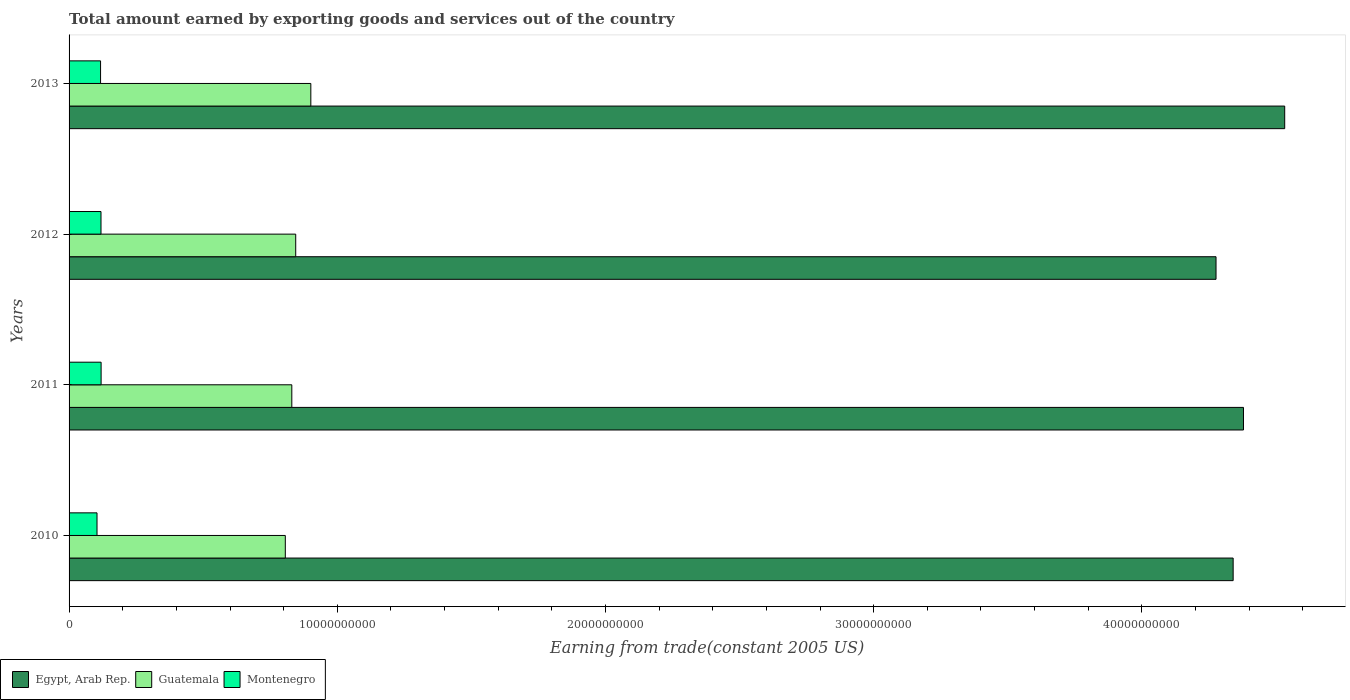How many groups of bars are there?
Your answer should be very brief. 4. Are the number of bars per tick equal to the number of legend labels?
Ensure brevity in your answer.  Yes. In how many cases, is the number of bars for a given year not equal to the number of legend labels?
Offer a very short reply. 0. What is the total amount earned by exporting goods and services in Egypt, Arab Rep. in 2013?
Your answer should be very brief. 4.53e+1. Across all years, what is the maximum total amount earned by exporting goods and services in Guatemala?
Provide a short and direct response. 9.01e+09. Across all years, what is the minimum total amount earned by exporting goods and services in Guatemala?
Your response must be concise. 8.06e+09. In which year was the total amount earned by exporting goods and services in Montenegro minimum?
Your answer should be very brief. 2010. What is the total total amount earned by exporting goods and services in Egypt, Arab Rep. in the graph?
Provide a succinct answer. 1.75e+11. What is the difference between the total amount earned by exporting goods and services in Montenegro in 2012 and that in 2013?
Provide a succinct answer. 1.59e+07. What is the difference between the total amount earned by exporting goods and services in Guatemala in 2010 and the total amount earned by exporting goods and services in Egypt, Arab Rep. in 2011?
Your answer should be compact. -3.57e+1. What is the average total amount earned by exporting goods and services in Guatemala per year?
Ensure brevity in your answer.  8.46e+09. In the year 2010, what is the difference between the total amount earned by exporting goods and services in Guatemala and total amount earned by exporting goods and services in Montenegro?
Keep it short and to the point. 7.02e+09. In how many years, is the total amount earned by exporting goods and services in Montenegro greater than 32000000000 US$?
Make the answer very short. 0. What is the ratio of the total amount earned by exporting goods and services in Montenegro in 2010 to that in 2012?
Provide a succinct answer. 0.88. Is the difference between the total amount earned by exporting goods and services in Guatemala in 2011 and 2013 greater than the difference between the total amount earned by exporting goods and services in Montenegro in 2011 and 2013?
Provide a succinct answer. No. What is the difference between the highest and the second highest total amount earned by exporting goods and services in Egypt, Arab Rep.?
Make the answer very short. 1.54e+09. What is the difference between the highest and the lowest total amount earned by exporting goods and services in Egypt, Arab Rep.?
Make the answer very short. 2.56e+09. In how many years, is the total amount earned by exporting goods and services in Guatemala greater than the average total amount earned by exporting goods and services in Guatemala taken over all years?
Offer a very short reply. 1. What does the 1st bar from the top in 2010 represents?
Your answer should be very brief. Montenegro. What does the 3rd bar from the bottom in 2012 represents?
Your answer should be compact. Montenegro. Are the values on the major ticks of X-axis written in scientific E-notation?
Ensure brevity in your answer.  No. Does the graph contain grids?
Give a very brief answer. No. How many legend labels are there?
Provide a short and direct response. 3. What is the title of the graph?
Give a very brief answer. Total amount earned by exporting goods and services out of the country. Does "Mali" appear as one of the legend labels in the graph?
Your response must be concise. No. What is the label or title of the X-axis?
Give a very brief answer. Earning from trade(constant 2005 US). What is the label or title of the Y-axis?
Offer a terse response. Years. What is the Earning from trade(constant 2005 US) in Egypt, Arab Rep. in 2010?
Your answer should be very brief. 4.34e+1. What is the Earning from trade(constant 2005 US) in Guatemala in 2010?
Keep it short and to the point. 8.06e+09. What is the Earning from trade(constant 2005 US) in Montenegro in 2010?
Your answer should be compact. 1.04e+09. What is the Earning from trade(constant 2005 US) of Egypt, Arab Rep. in 2011?
Make the answer very short. 4.38e+1. What is the Earning from trade(constant 2005 US) of Guatemala in 2011?
Offer a terse response. 8.31e+09. What is the Earning from trade(constant 2005 US) of Montenegro in 2011?
Provide a succinct answer. 1.19e+09. What is the Earning from trade(constant 2005 US) of Egypt, Arab Rep. in 2012?
Your answer should be compact. 4.28e+1. What is the Earning from trade(constant 2005 US) in Guatemala in 2012?
Provide a short and direct response. 8.45e+09. What is the Earning from trade(constant 2005 US) in Montenegro in 2012?
Ensure brevity in your answer.  1.19e+09. What is the Earning from trade(constant 2005 US) in Egypt, Arab Rep. in 2013?
Provide a succinct answer. 4.53e+1. What is the Earning from trade(constant 2005 US) in Guatemala in 2013?
Give a very brief answer. 9.01e+09. What is the Earning from trade(constant 2005 US) in Montenegro in 2013?
Your answer should be compact. 1.17e+09. Across all years, what is the maximum Earning from trade(constant 2005 US) in Egypt, Arab Rep.?
Offer a very short reply. 4.53e+1. Across all years, what is the maximum Earning from trade(constant 2005 US) of Guatemala?
Provide a succinct answer. 9.01e+09. Across all years, what is the maximum Earning from trade(constant 2005 US) in Montenegro?
Provide a short and direct response. 1.19e+09. Across all years, what is the minimum Earning from trade(constant 2005 US) of Egypt, Arab Rep.?
Give a very brief answer. 4.28e+1. Across all years, what is the minimum Earning from trade(constant 2005 US) in Guatemala?
Provide a succinct answer. 8.06e+09. Across all years, what is the minimum Earning from trade(constant 2005 US) of Montenegro?
Your answer should be compact. 1.04e+09. What is the total Earning from trade(constant 2005 US) of Egypt, Arab Rep. in the graph?
Ensure brevity in your answer.  1.75e+11. What is the total Earning from trade(constant 2005 US) of Guatemala in the graph?
Make the answer very short. 3.38e+1. What is the total Earning from trade(constant 2005 US) in Montenegro in the graph?
Provide a succinct answer. 4.60e+09. What is the difference between the Earning from trade(constant 2005 US) of Egypt, Arab Rep. in 2010 and that in 2011?
Offer a very short reply. -3.85e+08. What is the difference between the Earning from trade(constant 2005 US) of Guatemala in 2010 and that in 2011?
Offer a terse response. -2.43e+08. What is the difference between the Earning from trade(constant 2005 US) in Montenegro in 2010 and that in 2011?
Offer a terse response. -1.52e+08. What is the difference between the Earning from trade(constant 2005 US) in Egypt, Arab Rep. in 2010 and that in 2012?
Give a very brief answer. 6.38e+08. What is the difference between the Earning from trade(constant 2005 US) of Guatemala in 2010 and that in 2012?
Give a very brief answer. -3.88e+08. What is the difference between the Earning from trade(constant 2005 US) in Montenegro in 2010 and that in 2012?
Keep it short and to the point. -1.48e+08. What is the difference between the Earning from trade(constant 2005 US) of Egypt, Arab Rep. in 2010 and that in 2013?
Keep it short and to the point. -1.92e+09. What is the difference between the Earning from trade(constant 2005 US) of Guatemala in 2010 and that in 2013?
Your response must be concise. -9.51e+08. What is the difference between the Earning from trade(constant 2005 US) of Montenegro in 2010 and that in 2013?
Your answer should be very brief. -1.32e+08. What is the difference between the Earning from trade(constant 2005 US) of Egypt, Arab Rep. in 2011 and that in 2012?
Provide a succinct answer. 1.02e+09. What is the difference between the Earning from trade(constant 2005 US) in Guatemala in 2011 and that in 2012?
Offer a terse response. -1.46e+08. What is the difference between the Earning from trade(constant 2005 US) in Montenegro in 2011 and that in 2012?
Offer a very short reply. 4.06e+06. What is the difference between the Earning from trade(constant 2005 US) of Egypt, Arab Rep. in 2011 and that in 2013?
Provide a short and direct response. -1.54e+09. What is the difference between the Earning from trade(constant 2005 US) in Guatemala in 2011 and that in 2013?
Your answer should be very brief. -7.09e+08. What is the difference between the Earning from trade(constant 2005 US) in Montenegro in 2011 and that in 2013?
Give a very brief answer. 2.00e+07. What is the difference between the Earning from trade(constant 2005 US) in Egypt, Arab Rep. in 2012 and that in 2013?
Your response must be concise. -2.56e+09. What is the difference between the Earning from trade(constant 2005 US) in Guatemala in 2012 and that in 2013?
Make the answer very short. -5.63e+08. What is the difference between the Earning from trade(constant 2005 US) in Montenegro in 2012 and that in 2013?
Offer a very short reply. 1.59e+07. What is the difference between the Earning from trade(constant 2005 US) in Egypt, Arab Rep. in 2010 and the Earning from trade(constant 2005 US) in Guatemala in 2011?
Keep it short and to the point. 3.51e+1. What is the difference between the Earning from trade(constant 2005 US) in Egypt, Arab Rep. in 2010 and the Earning from trade(constant 2005 US) in Montenegro in 2011?
Give a very brief answer. 4.22e+1. What is the difference between the Earning from trade(constant 2005 US) in Guatemala in 2010 and the Earning from trade(constant 2005 US) in Montenegro in 2011?
Make the answer very short. 6.87e+09. What is the difference between the Earning from trade(constant 2005 US) in Egypt, Arab Rep. in 2010 and the Earning from trade(constant 2005 US) in Guatemala in 2012?
Keep it short and to the point. 3.50e+1. What is the difference between the Earning from trade(constant 2005 US) in Egypt, Arab Rep. in 2010 and the Earning from trade(constant 2005 US) in Montenegro in 2012?
Provide a succinct answer. 4.22e+1. What is the difference between the Earning from trade(constant 2005 US) in Guatemala in 2010 and the Earning from trade(constant 2005 US) in Montenegro in 2012?
Your response must be concise. 6.87e+09. What is the difference between the Earning from trade(constant 2005 US) in Egypt, Arab Rep. in 2010 and the Earning from trade(constant 2005 US) in Guatemala in 2013?
Give a very brief answer. 3.44e+1. What is the difference between the Earning from trade(constant 2005 US) in Egypt, Arab Rep. in 2010 and the Earning from trade(constant 2005 US) in Montenegro in 2013?
Ensure brevity in your answer.  4.22e+1. What is the difference between the Earning from trade(constant 2005 US) of Guatemala in 2010 and the Earning from trade(constant 2005 US) of Montenegro in 2013?
Provide a short and direct response. 6.89e+09. What is the difference between the Earning from trade(constant 2005 US) in Egypt, Arab Rep. in 2011 and the Earning from trade(constant 2005 US) in Guatemala in 2012?
Your response must be concise. 3.53e+1. What is the difference between the Earning from trade(constant 2005 US) of Egypt, Arab Rep. in 2011 and the Earning from trade(constant 2005 US) of Montenegro in 2012?
Provide a succinct answer. 4.26e+1. What is the difference between the Earning from trade(constant 2005 US) in Guatemala in 2011 and the Earning from trade(constant 2005 US) in Montenegro in 2012?
Provide a succinct answer. 7.11e+09. What is the difference between the Earning from trade(constant 2005 US) of Egypt, Arab Rep. in 2011 and the Earning from trade(constant 2005 US) of Guatemala in 2013?
Your answer should be compact. 3.48e+1. What is the difference between the Earning from trade(constant 2005 US) of Egypt, Arab Rep. in 2011 and the Earning from trade(constant 2005 US) of Montenegro in 2013?
Ensure brevity in your answer.  4.26e+1. What is the difference between the Earning from trade(constant 2005 US) of Guatemala in 2011 and the Earning from trade(constant 2005 US) of Montenegro in 2013?
Ensure brevity in your answer.  7.13e+09. What is the difference between the Earning from trade(constant 2005 US) in Egypt, Arab Rep. in 2012 and the Earning from trade(constant 2005 US) in Guatemala in 2013?
Your answer should be very brief. 3.38e+1. What is the difference between the Earning from trade(constant 2005 US) in Egypt, Arab Rep. in 2012 and the Earning from trade(constant 2005 US) in Montenegro in 2013?
Ensure brevity in your answer.  4.16e+1. What is the difference between the Earning from trade(constant 2005 US) in Guatemala in 2012 and the Earning from trade(constant 2005 US) in Montenegro in 2013?
Your response must be concise. 7.28e+09. What is the average Earning from trade(constant 2005 US) of Egypt, Arab Rep. per year?
Your answer should be very brief. 4.38e+1. What is the average Earning from trade(constant 2005 US) in Guatemala per year?
Provide a short and direct response. 8.46e+09. What is the average Earning from trade(constant 2005 US) in Montenegro per year?
Make the answer very short. 1.15e+09. In the year 2010, what is the difference between the Earning from trade(constant 2005 US) in Egypt, Arab Rep. and Earning from trade(constant 2005 US) in Guatemala?
Provide a short and direct response. 3.53e+1. In the year 2010, what is the difference between the Earning from trade(constant 2005 US) of Egypt, Arab Rep. and Earning from trade(constant 2005 US) of Montenegro?
Provide a succinct answer. 4.24e+1. In the year 2010, what is the difference between the Earning from trade(constant 2005 US) in Guatemala and Earning from trade(constant 2005 US) in Montenegro?
Offer a terse response. 7.02e+09. In the year 2011, what is the difference between the Earning from trade(constant 2005 US) of Egypt, Arab Rep. and Earning from trade(constant 2005 US) of Guatemala?
Provide a succinct answer. 3.55e+1. In the year 2011, what is the difference between the Earning from trade(constant 2005 US) of Egypt, Arab Rep. and Earning from trade(constant 2005 US) of Montenegro?
Provide a short and direct response. 4.26e+1. In the year 2011, what is the difference between the Earning from trade(constant 2005 US) of Guatemala and Earning from trade(constant 2005 US) of Montenegro?
Your response must be concise. 7.11e+09. In the year 2012, what is the difference between the Earning from trade(constant 2005 US) of Egypt, Arab Rep. and Earning from trade(constant 2005 US) of Guatemala?
Keep it short and to the point. 3.43e+1. In the year 2012, what is the difference between the Earning from trade(constant 2005 US) of Egypt, Arab Rep. and Earning from trade(constant 2005 US) of Montenegro?
Offer a terse response. 4.16e+1. In the year 2012, what is the difference between the Earning from trade(constant 2005 US) of Guatemala and Earning from trade(constant 2005 US) of Montenegro?
Your answer should be compact. 7.26e+09. In the year 2013, what is the difference between the Earning from trade(constant 2005 US) of Egypt, Arab Rep. and Earning from trade(constant 2005 US) of Guatemala?
Ensure brevity in your answer.  3.63e+1. In the year 2013, what is the difference between the Earning from trade(constant 2005 US) in Egypt, Arab Rep. and Earning from trade(constant 2005 US) in Montenegro?
Offer a terse response. 4.42e+1. In the year 2013, what is the difference between the Earning from trade(constant 2005 US) of Guatemala and Earning from trade(constant 2005 US) of Montenegro?
Provide a short and direct response. 7.84e+09. What is the ratio of the Earning from trade(constant 2005 US) of Guatemala in 2010 to that in 2011?
Offer a terse response. 0.97. What is the ratio of the Earning from trade(constant 2005 US) in Montenegro in 2010 to that in 2011?
Give a very brief answer. 0.87. What is the ratio of the Earning from trade(constant 2005 US) of Egypt, Arab Rep. in 2010 to that in 2012?
Provide a short and direct response. 1.01. What is the ratio of the Earning from trade(constant 2005 US) in Guatemala in 2010 to that in 2012?
Ensure brevity in your answer.  0.95. What is the ratio of the Earning from trade(constant 2005 US) in Montenegro in 2010 to that in 2012?
Offer a very short reply. 0.88. What is the ratio of the Earning from trade(constant 2005 US) of Egypt, Arab Rep. in 2010 to that in 2013?
Your answer should be very brief. 0.96. What is the ratio of the Earning from trade(constant 2005 US) of Guatemala in 2010 to that in 2013?
Your answer should be compact. 0.89. What is the ratio of the Earning from trade(constant 2005 US) in Montenegro in 2010 to that in 2013?
Provide a short and direct response. 0.89. What is the ratio of the Earning from trade(constant 2005 US) in Egypt, Arab Rep. in 2011 to that in 2012?
Your answer should be compact. 1.02. What is the ratio of the Earning from trade(constant 2005 US) in Guatemala in 2011 to that in 2012?
Offer a terse response. 0.98. What is the ratio of the Earning from trade(constant 2005 US) of Egypt, Arab Rep. in 2011 to that in 2013?
Provide a short and direct response. 0.97. What is the ratio of the Earning from trade(constant 2005 US) in Guatemala in 2011 to that in 2013?
Give a very brief answer. 0.92. What is the ratio of the Earning from trade(constant 2005 US) in Montenegro in 2011 to that in 2013?
Your answer should be very brief. 1.02. What is the ratio of the Earning from trade(constant 2005 US) in Egypt, Arab Rep. in 2012 to that in 2013?
Make the answer very short. 0.94. What is the ratio of the Earning from trade(constant 2005 US) in Guatemala in 2012 to that in 2013?
Provide a short and direct response. 0.94. What is the ratio of the Earning from trade(constant 2005 US) in Montenegro in 2012 to that in 2013?
Your answer should be very brief. 1.01. What is the difference between the highest and the second highest Earning from trade(constant 2005 US) of Egypt, Arab Rep.?
Provide a short and direct response. 1.54e+09. What is the difference between the highest and the second highest Earning from trade(constant 2005 US) in Guatemala?
Your response must be concise. 5.63e+08. What is the difference between the highest and the second highest Earning from trade(constant 2005 US) of Montenegro?
Offer a very short reply. 4.06e+06. What is the difference between the highest and the lowest Earning from trade(constant 2005 US) in Egypt, Arab Rep.?
Ensure brevity in your answer.  2.56e+09. What is the difference between the highest and the lowest Earning from trade(constant 2005 US) in Guatemala?
Ensure brevity in your answer.  9.51e+08. What is the difference between the highest and the lowest Earning from trade(constant 2005 US) of Montenegro?
Your response must be concise. 1.52e+08. 